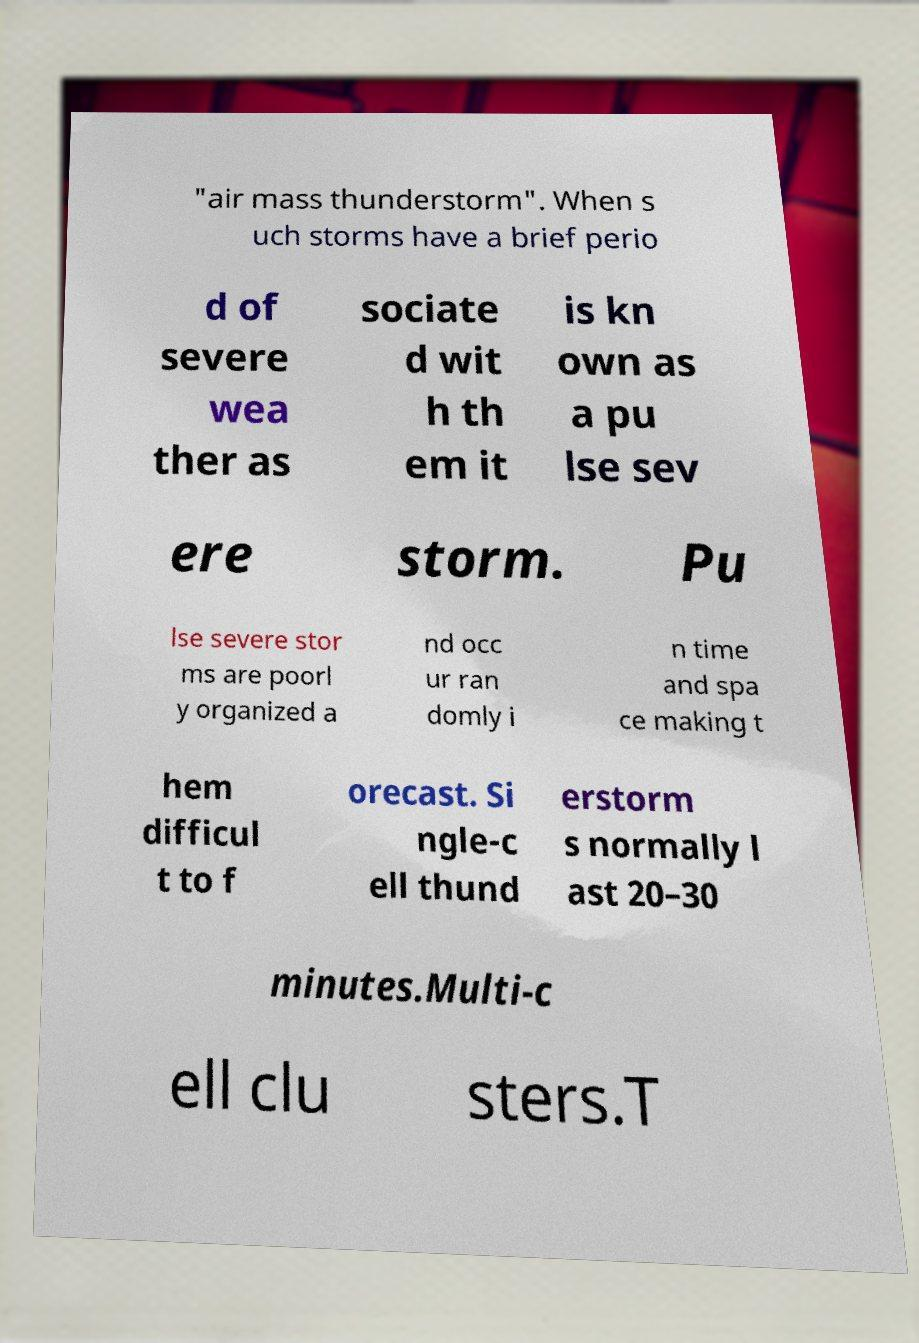Can you read and provide the text displayed in the image?This photo seems to have some interesting text. Can you extract and type it out for me? "air mass thunderstorm". When s uch storms have a brief perio d of severe wea ther as sociate d wit h th em it is kn own as a pu lse sev ere storm. Pu lse severe stor ms are poorl y organized a nd occ ur ran domly i n time and spa ce making t hem difficul t to f orecast. Si ngle-c ell thund erstorm s normally l ast 20–30 minutes.Multi-c ell clu sters.T 